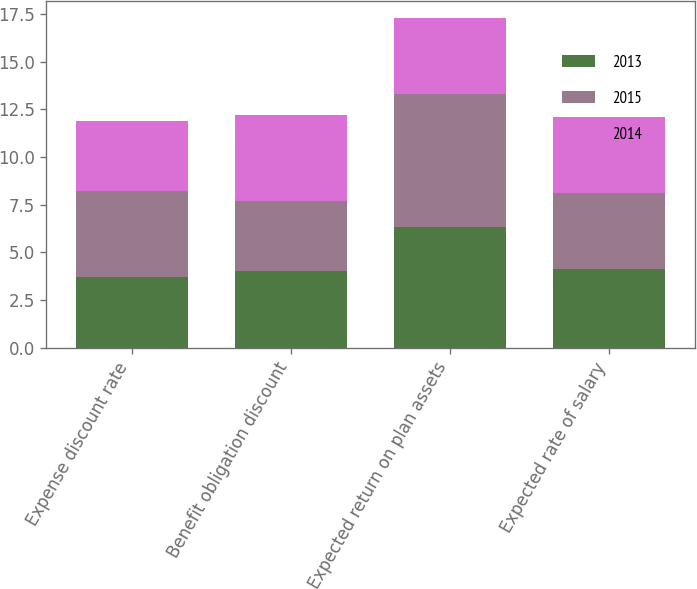Convert chart. <chart><loc_0><loc_0><loc_500><loc_500><stacked_bar_chart><ecel><fcel>Expense discount rate<fcel>Benefit obligation discount<fcel>Expected return on plan assets<fcel>Expected rate of salary<nl><fcel>2013<fcel>3.7<fcel>4<fcel>6.3<fcel>4.1<nl><fcel>2015<fcel>4.5<fcel>3.7<fcel>7<fcel>4<nl><fcel>2014<fcel>3.7<fcel>4.5<fcel>4<fcel>4<nl></chart> 